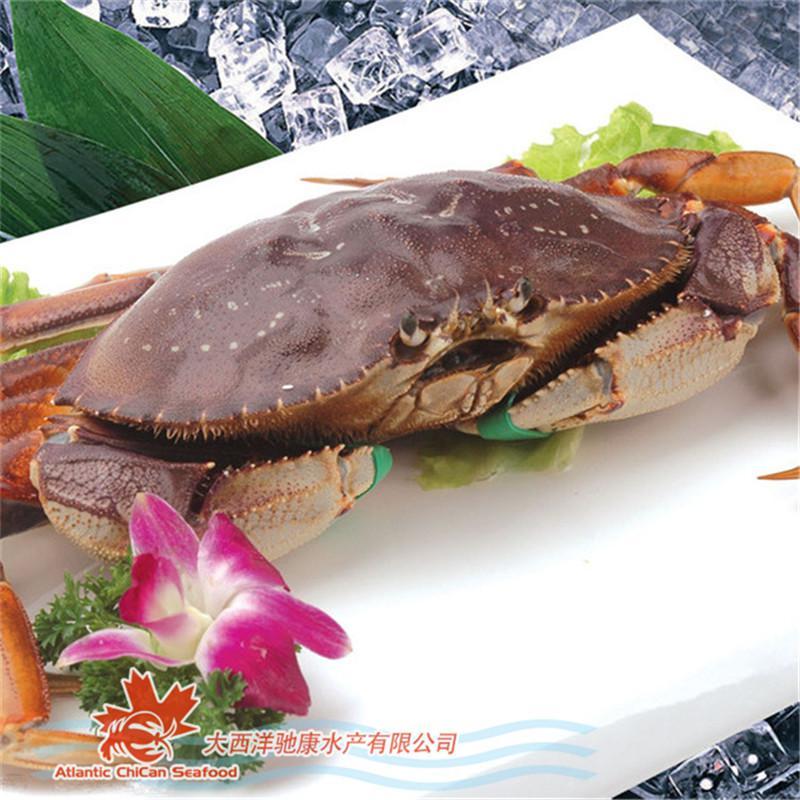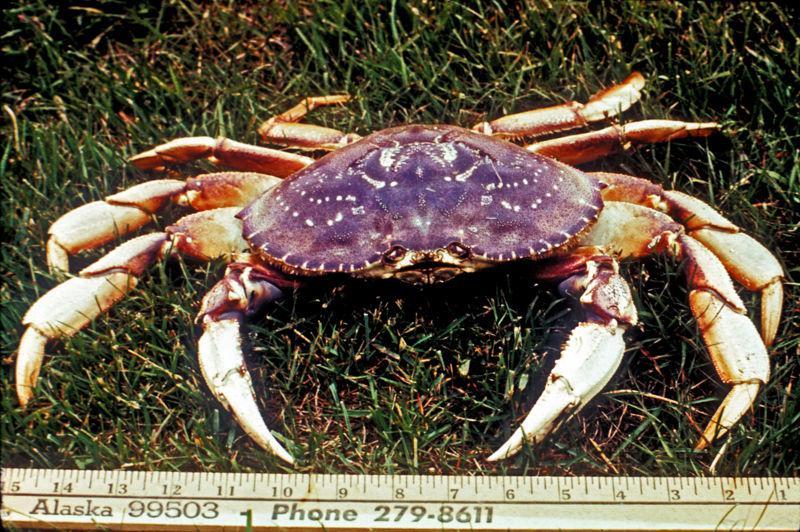The first image is the image on the left, the second image is the image on the right. Given the left and right images, does the statement "There are two crabs" hold true? Answer yes or no. Yes. 